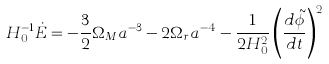<formula> <loc_0><loc_0><loc_500><loc_500>H _ { 0 } ^ { - 1 } \dot { E } = - \frac { 3 } { 2 } \Omega _ { M } a ^ { - 3 } - 2 \Omega _ { r } a ^ { - 4 } - \frac { 1 } { 2 H _ { 0 } ^ { 2 } } \left ( \frac { d \tilde { \phi } } { d t } \right ) ^ { 2 } \,</formula> 